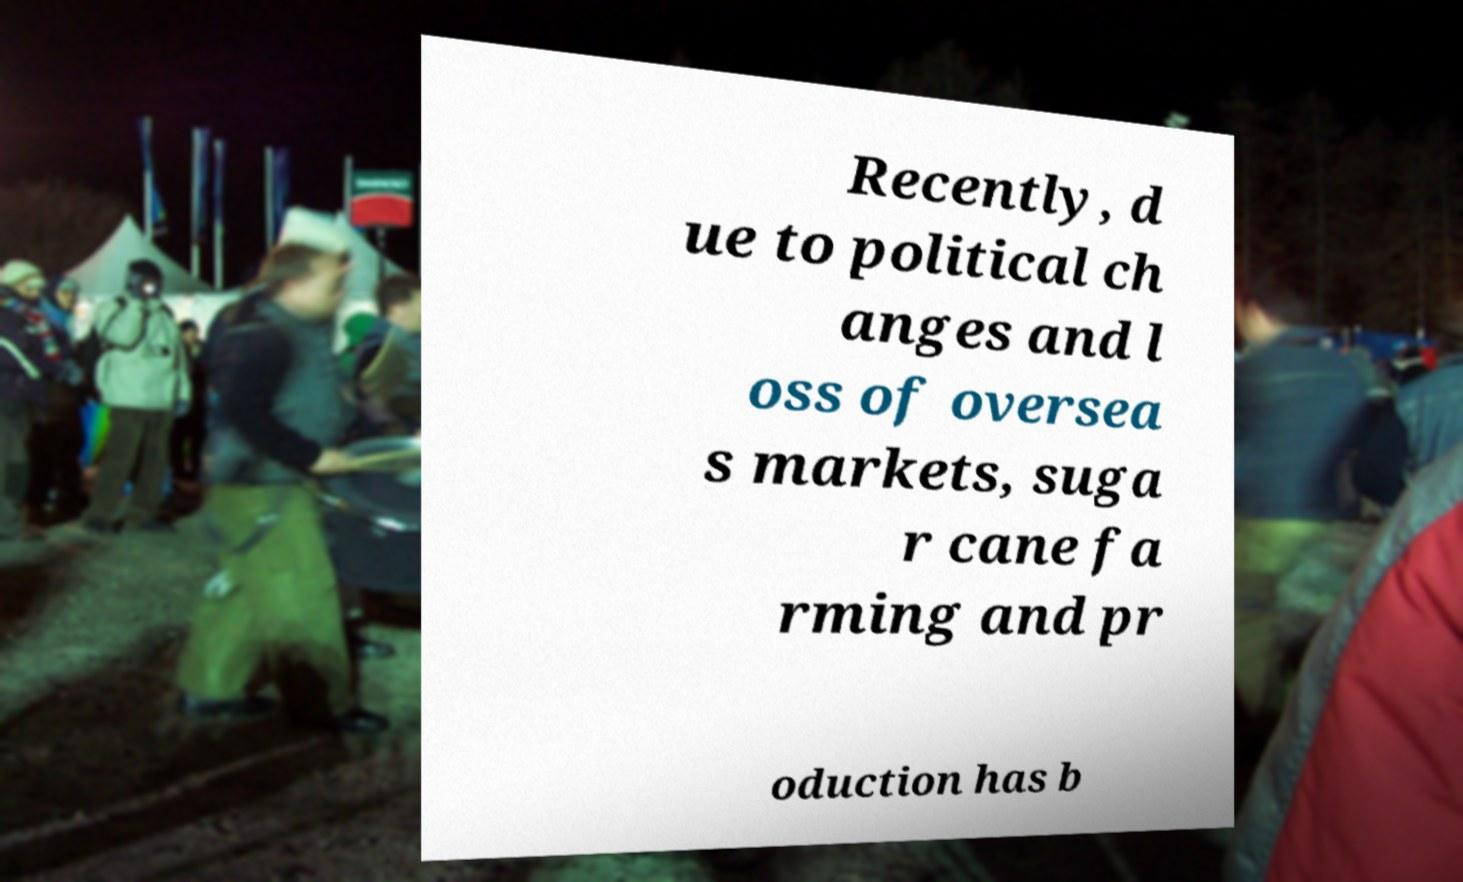Please read and relay the text visible in this image. What does it say? Recently, d ue to political ch anges and l oss of oversea s markets, suga r cane fa rming and pr oduction has b 